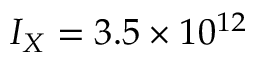Convert formula to latex. <formula><loc_0><loc_0><loc_500><loc_500>I _ { X } = 3 . 5 \times 1 0 ^ { 1 2 }</formula> 